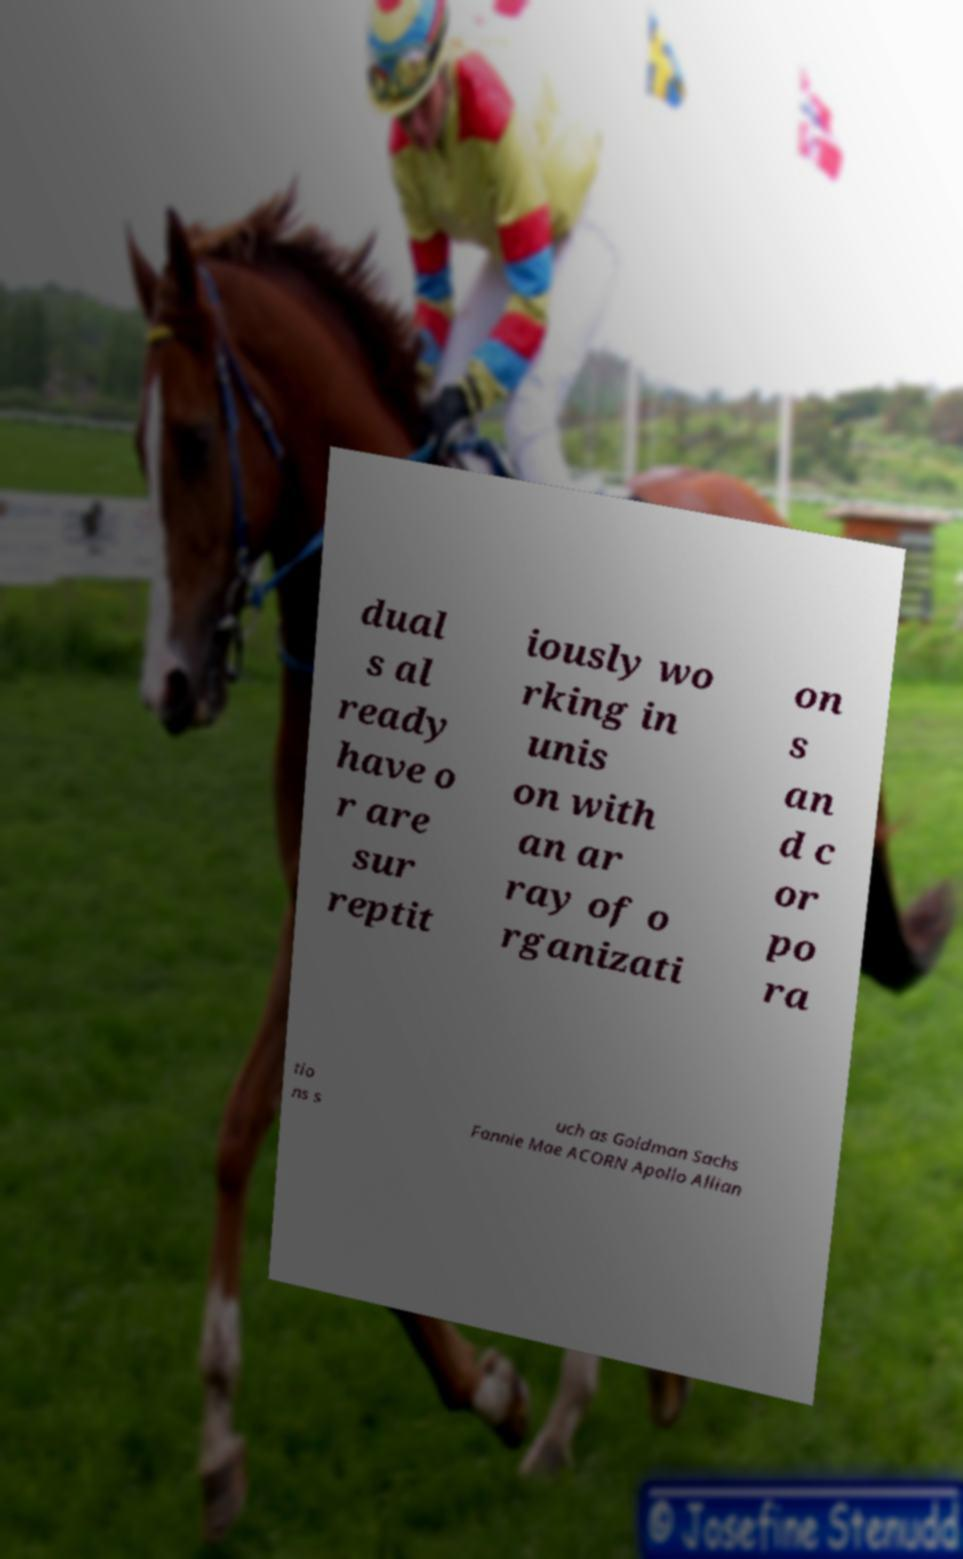Please read and relay the text visible in this image. What does it say? dual s al ready have o r are sur reptit iously wo rking in unis on with an ar ray of o rganizati on s an d c or po ra tio ns s uch as Goldman Sachs Fannie Mae ACORN Apollo Allian 